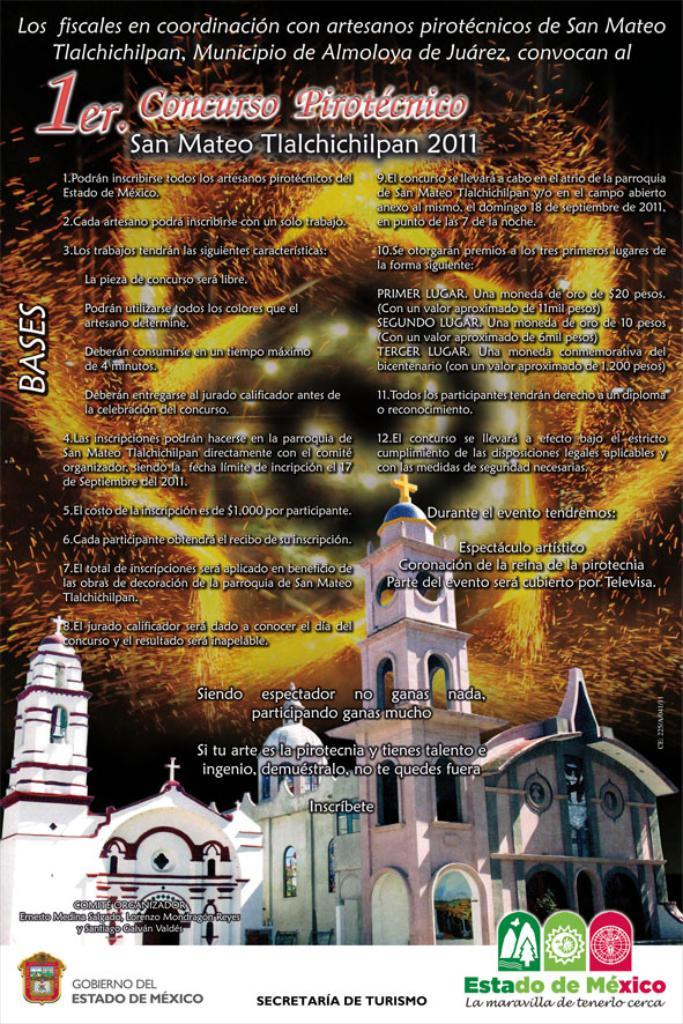What type of structures can be seen in the image? There are buildings in the image. What else is visible on the image besides the buildings? There are watermarks and writing in the image. What is the color of the background in the image? The background of the image is black. What type of word can be seen in the image? There is no specific word mentioned or visible in the image; it only contains writing in general. Can you see a turkey in the image? No, there is no turkey present in the image. 